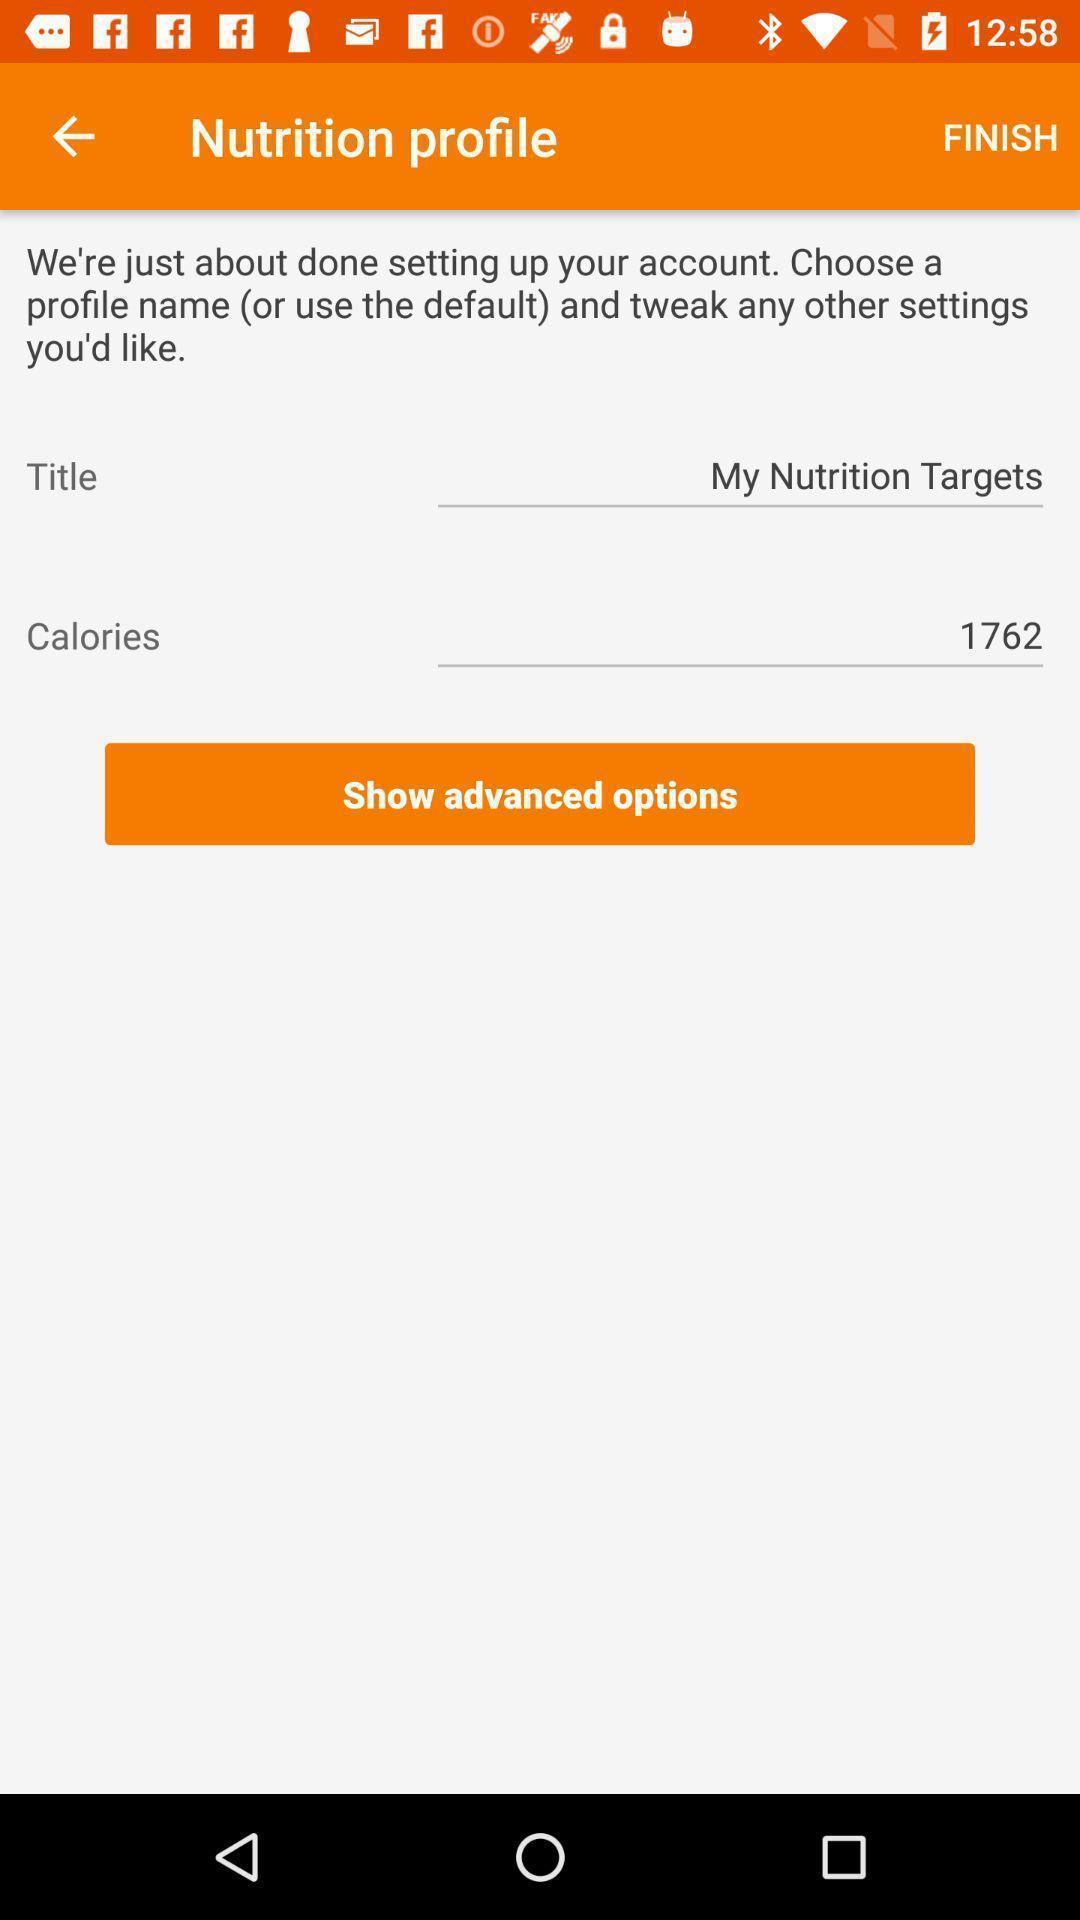What details can you identify in this image? Profile settings of a fitness app. 